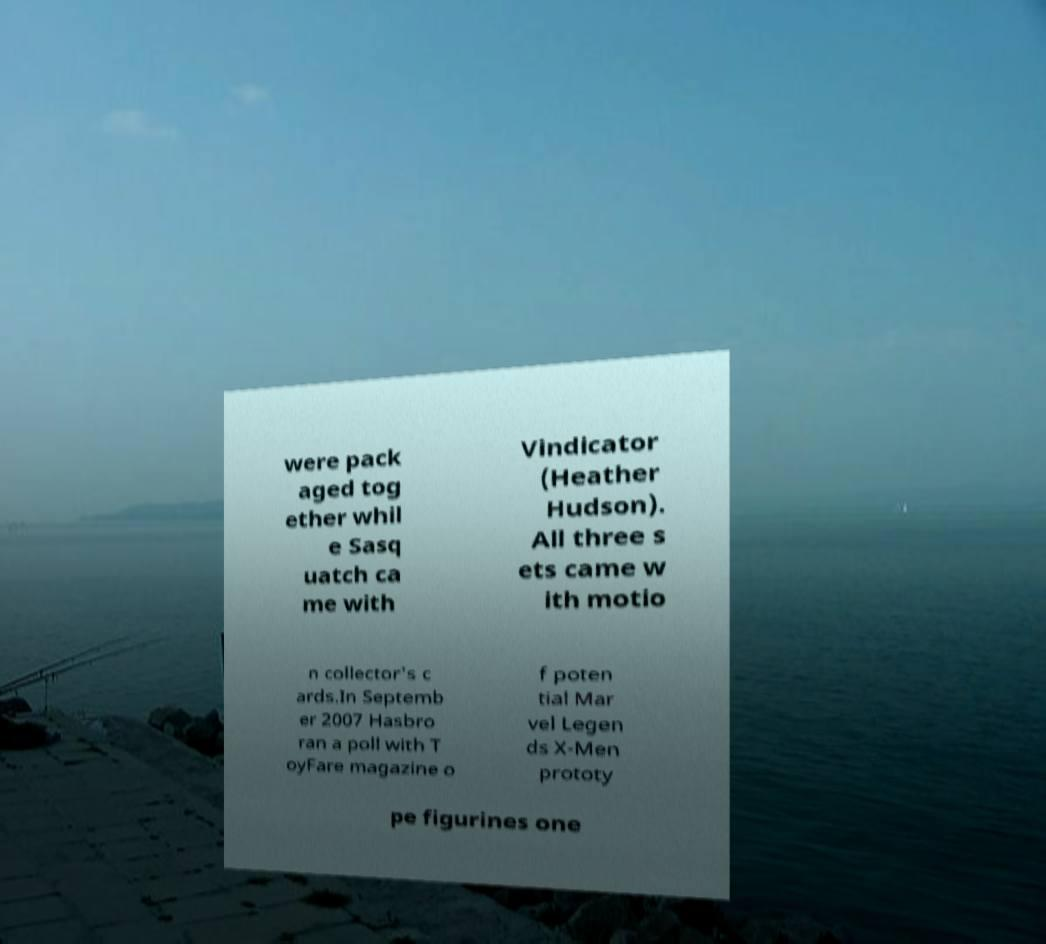What messages or text are displayed in this image? I need them in a readable, typed format. were pack aged tog ether whil e Sasq uatch ca me with Vindicator (Heather Hudson). All three s ets came w ith motio n collector's c ards.In Septemb er 2007 Hasbro ran a poll with T oyFare magazine o f poten tial Mar vel Legen ds X-Men prototy pe figurines one 